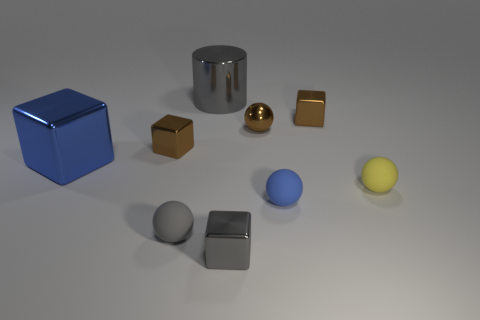Subtract all gray cylinders. How many brown cubes are left? 2 Subtract all blue cubes. How many cubes are left? 3 Subtract all yellow spheres. How many spheres are left? 3 Add 1 small blue rubber spheres. How many objects exist? 10 Subtract all spheres. How many objects are left? 5 Subtract all purple balls. Subtract all green cylinders. How many balls are left? 4 Add 6 gray rubber things. How many gray rubber things are left? 7 Add 5 tiny red objects. How many tiny red objects exist? 5 Subtract 0 green spheres. How many objects are left? 9 Subtract all tiny yellow rubber things. Subtract all gray cylinders. How many objects are left? 7 